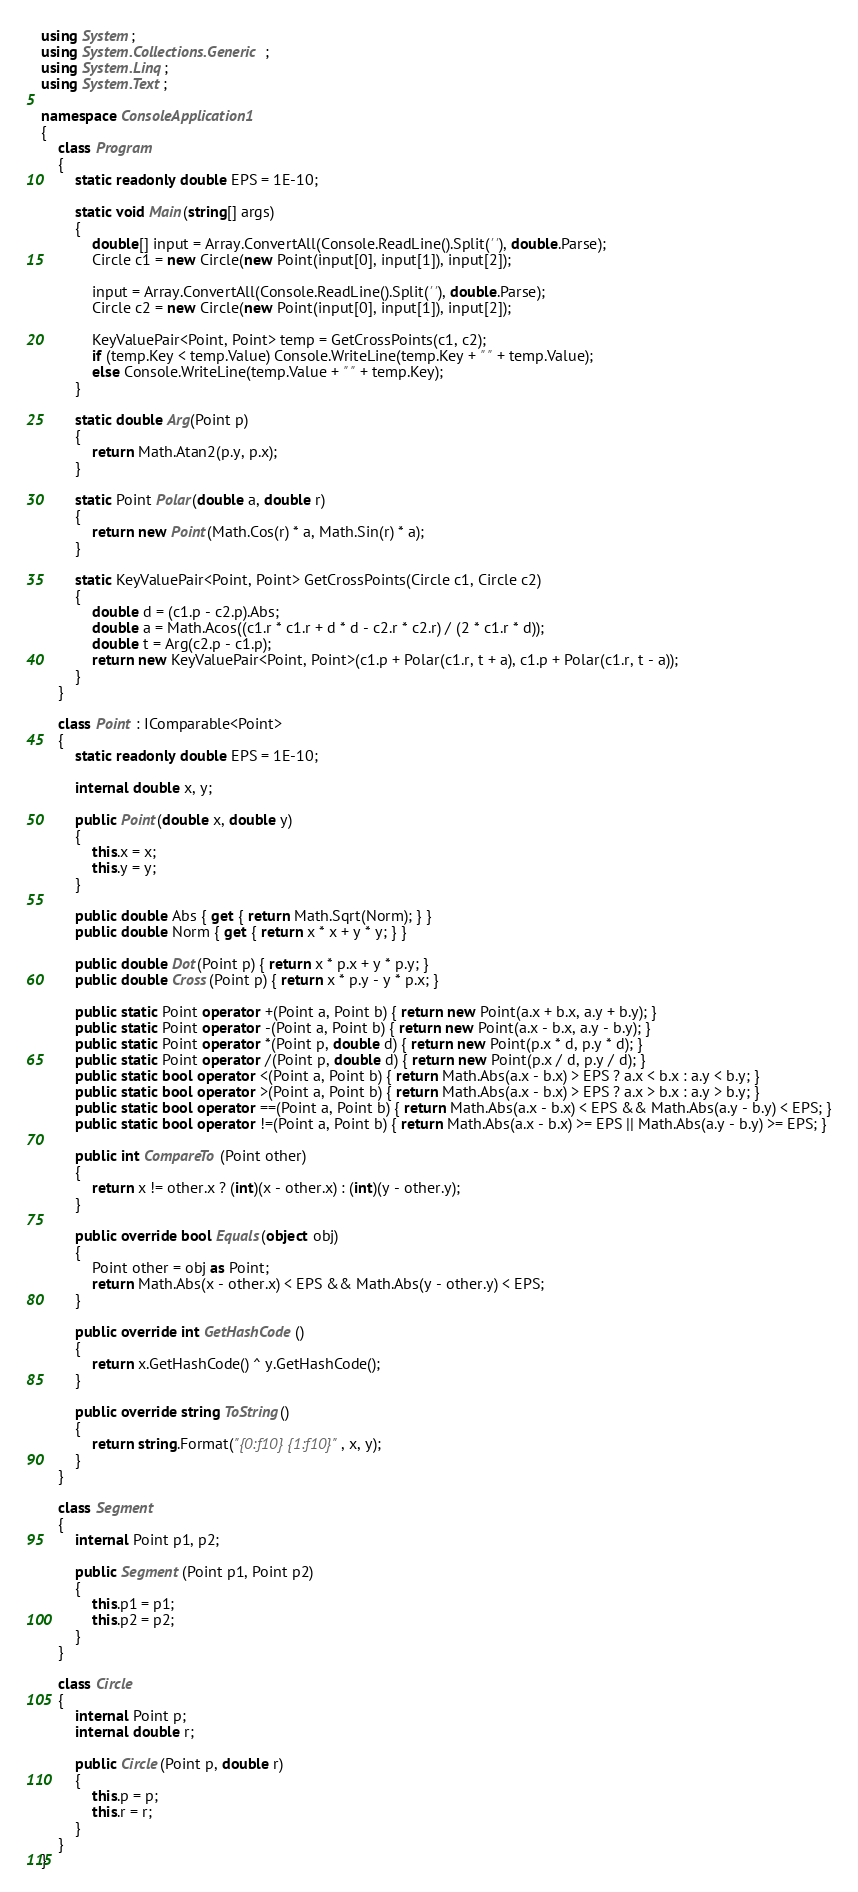<code> <loc_0><loc_0><loc_500><loc_500><_C#_>using System;
using System.Collections.Generic;
using System.Linq;
using System.Text;

namespace ConsoleApplication1
{
    class Program
    {
        static readonly double EPS = 1E-10;

        static void Main(string[] args)
        {
            double[] input = Array.ConvertAll(Console.ReadLine().Split(' '), double.Parse);
            Circle c1 = new Circle(new Point(input[0], input[1]), input[2]);

            input = Array.ConvertAll(Console.ReadLine().Split(' '), double.Parse);
            Circle c2 = new Circle(new Point(input[0], input[1]), input[2]);

            KeyValuePair<Point, Point> temp = GetCrossPoints(c1, c2);
            if (temp.Key < temp.Value) Console.WriteLine(temp.Key + " " + temp.Value);
            else Console.WriteLine(temp.Value + " " + temp.Key);
        }

        static double Arg(Point p)
        {
            return Math.Atan2(p.y, p.x);
        }

        static Point Polar(double a, double r)
        {
            return new Point(Math.Cos(r) * a, Math.Sin(r) * a);
        }

        static KeyValuePair<Point, Point> GetCrossPoints(Circle c1, Circle c2)
        {
            double d = (c1.p - c2.p).Abs;
            double a = Math.Acos((c1.r * c1.r + d * d - c2.r * c2.r) / (2 * c1.r * d));
            double t = Arg(c2.p - c1.p);
            return new KeyValuePair<Point, Point>(c1.p + Polar(c1.r, t + a), c1.p + Polar(c1.r, t - a));
        }
    }

    class Point : IComparable<Point>
    {
        static readonly double EPS = 1E-10;

        internal double x, y;

        public Point(double x, double y)
        {
            this.x = x;
            this.y = y;
        }

        public double Abs { get { return Math.Sqrt(Norm); } }
        public double Norm { get { return x * x + y * y; } }

        public double Dot(Point p) { return x * p.x + y * p.y; }
        public double Cross(Point p) { return x * p.y - y * p.x; }

        public static Point operator +(Point a, Point b) { return new Point(a.x + b.x, a.y + b.y); }
        public static Point operator -(Point a, Point b) { return new Point(a.x - b.x, a.y - b.y); }
        public static Point operator *(Point p, double d) { return new Point(p.x * d, p.y * d); }
        public static Point operator /(Point p, double d) { return new Point(p.x / d, p.y / d); }
        public static bool operator <(Point a, Point b) { return Math.Abs(a.x - b.x) > EPS ? a.x < b.x : a.y < b.y; }
        public static bool operator >(Point a, Point b) { return Math.Abs(a.x - b.x) > EPS ? a.x > b.x : a.y > b.y; }
        public static bool operator ==(Point a, Point b) { return Math.Abs(a.x - b.x) < EPS && Math.Abs(a.y - b.y) < EPS; }
        public static bool operator !=(Point a, Point b) { return Math.Abs(a.x - b.x) >= EPS || Math.Abs(a.y - b.y) >= EPS; }

        public int CompareTo(Point other)
        {
            return x != other.x ? (int)(x - other.x) : (int)(y - other.y);
        }

        public override bool Equals(object obj)
        {
            Point other = obj as Point;
            return Math.Abs(x - other.x) < EPS && Math.Abs(y - other.y) < EPS;
        }

        public override int GetHashCode()
        {
            return x.GetHashCode() ^ y.GetHashCode();
        }

        public override string ToString()
        {
            return string.Format("{0:f10} {1:f10}", x, y);
        }
    }

    class Segment
    {
        internal Point p1, p2;

        public Segment(Point p1, Point p2)
        {
            this.p1 = p1;
            this.p2 = p2;
        }
    }

    class Circle
    {
        internal Point p;
        internal double r;

        public Circle(Point p, double r)
        {
            this.p = p;
            this.r = r;
        }
    }
}</code> 